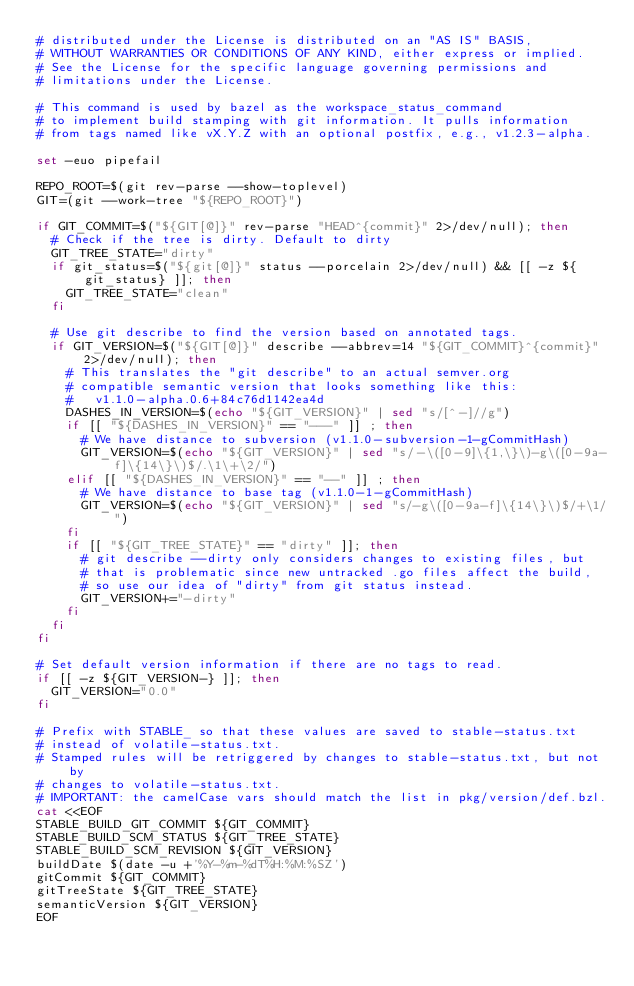<code> <loc_0><loc_0><loc_500><loc_500><_Bash_># distributed under the License is distributed on an "AS IS" BASIS,
# WITHOUT WARRANTIES OR CONDITIONS OF ANY KIND, either express or implied.
# See the License for the specific language governing permissions and
# limitations under the License.

# This command is used by bazel as the workspace_status_command
# to implement build stamping with git information. It pulls information
# from tags named like vX.Y.Z with an optional postfix, e.g., v1.2.3-alpha.

set -euo pipefail

REPO_ROOT=$(git rev-parse --show-toplevel)
GIT=(git --work-tree "${REPO_ROOT}")

if GIT_COMMIT=$("${GIT[@]}" rev-parse "HEAD^{commit}" 2>/dev/null); then
  # Check if the tree is dirty. Default to dirty
  GIT_TREE_STATE="dirty"
  if git_status=$("${git[@]}" status --porcelain 2>/dev/null) && [[ -z ${git_status} ]]; then
    GIT_TREE_STATE="clean"
  fi

  # Use git describe to find the version based on annotated tags.
  if GIT_VERSION=$("${GIT[@]}" describe --abbrev=14 "${GIT_COMMIT}^{commit}" 2>/dev/null); then
    # This translates the "git describe" to an actual semver.org
    # compatible semantic version that looks something like this:
    #   v1.1.0-alpha.0.6+84c76d1142ea4d
    DASHES_IN_VERSION=$(echo "${GIT_VERSION}" | sed "s/[^-]//g")
    if [[ "${DASHES_IN_VERSION}" == "---" ]] ; then
      # We have distance to subversion (v1.1.0-subversion-1-gCommitHash)
      GIT_VERSION=$(echo "${GIT_VERSION}" | sed "s/-\([0-9]\{1,\}\)-g\([0-9a-f]\{14\}\)$/.\1\+\2/")
    elif [[ "${DASHES_IN_VERSION}" == "--" ]] ; then
      # We have distance to base tag (v1.1.0-1-gCommitHash)
      GIT_VERSION=$(echo "${GIT_VERSION}" | sed "s/-g\([0-9a-f]\{14\}\)$/+\1/")
    fi
    if [[ "${GIT_TREE_STATE}" == "dirty" ]]; then
      # git describe --dirty only considers changes to existing files, but
      # that is problematic since new untracked .go files affect the build,
      # so use our idea of "dirty" from git status instead.
      GIT_VERSION+="-dirty"
    fi
  fi
fi

# Set default version information if there are no tags to read.
if [[ -z ${GIT_VERSION-} ]]; then
  GIT_VERSION="0.0"
fi

# Prefix with STABLE_ so that these values are saved to stable-status.txt
# instead of volatile-status.txt.
# Stamped rules will be retriggered by changes to stable-status.txt, but not by
# changes to volatile-status.txt.
# IMPORTANT: the camelCase vars should match the list in pkg/version/def.bzl.
cat <<EOF
STABLE_BUILD_GIT_COMMIT ${GIT_COMMIT}
STABLE_BUILD_SCM_STATUS ${GIT_TREE_STATE}
STABLE_BUILD_SCM_REVISION ${GIT_VERSION}
buildDate $(date -u +'%Y-%m-%dT%H:%M:%SZ')
gitCommit ${GIT_COMMIT}
gitTreeState ${GIT_TREE_STATE}
semanticVersion ${GIT_VERSION}
EOF
</code> 